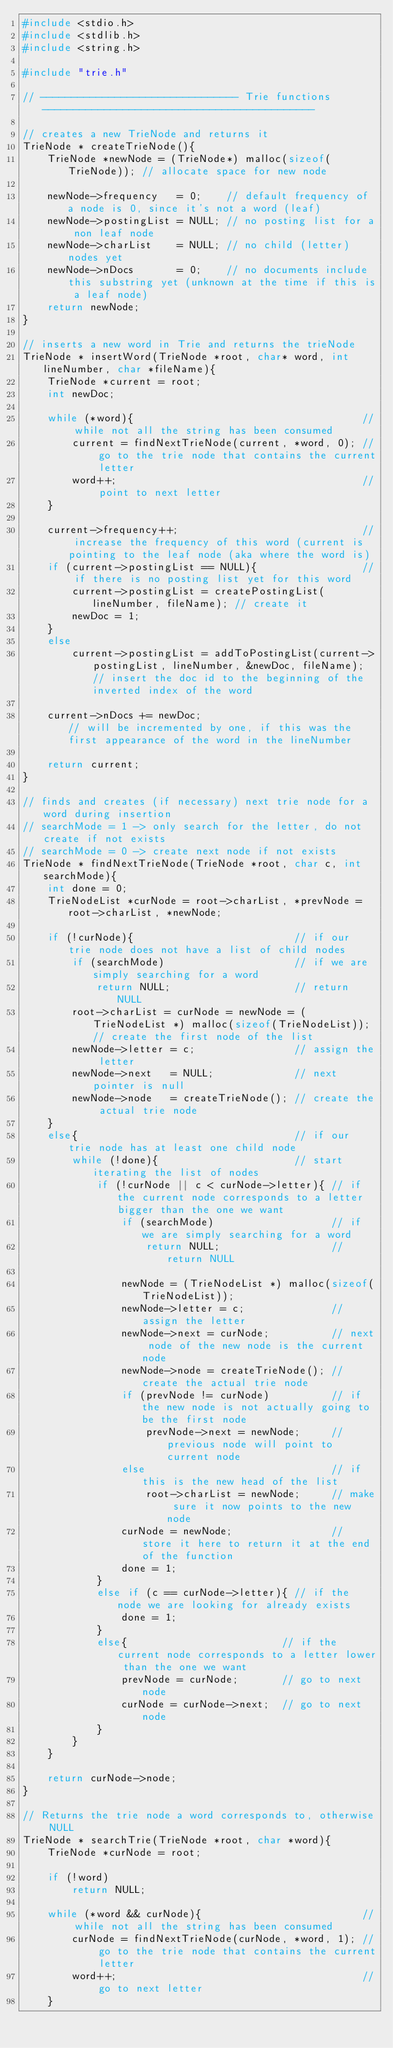<code> <loc_0><loc_0><loc_500><loc_500><_C_>#include <stdio.h>
#include <stdlib.h>
#include <string.h>

#include "trie.h"

// -------------------------------- Trie functions --------------------------------------------

// creates a new TrieNode and returns it
TrieNode * createTrieNode(){
    TrieNode *newNode = (TrieNode*) malloc(sizeof(TrieNode)); // allocate space for new node

    newNode->frequency   = 0;    // default frequency of a node is 0, since it's not a word (leaf)
    newNode->postingList = NULL; // no posting list for a non leaf node
    newNode->charList    = NULL; // no child (letter) nodes yet
    newNode->nDocs       = 0;    // no documents include this substring yet (unknown at the time if this is a leaf node)
    return newNode;
}

// inserts a new word in Trie and returns the trieNode
TrieNode * insertWord(TrieNode *root, char* word, int lineNumber, char *fileName){
    TrieNode *current = root;
    int newDoc;

    while (*word){                                     // while not all the string has been consumed
        current = findNextTrieNode(current, *word, 0); // go to the trie node that contains the current letter
        word++;                                        // point to next letter
    }

    current->frequency++;                              // increase the frequency of this word (current is pointing to the leaf node (aka where the word is)
    if (current->postingList == NULL){                 // if there is no posting list yet for this word
        current->postingList = createPostingList(lineNumber, fileName); // create it
        newDoc = 1;
    }
    else
        current->postingList = addToPostingList(current->postingList, lineNumber, &newDoc, fileName); // insert the doc id to the beginning of the inverted index of the word

    current->nDocs += newDoc;                           // will be incremented by one, if this was the first appearance of the word in the lineNumber

    return current;
}

// finds and creates (if necessary) next trie node for a word during insertion
// searchMode = 1 -> only search for the letter, do not create if not exists
// searchMode = 0 -> create next node if not exists
TrieNode * findNextTrieNode(TrieNode *root, char c, int searchMode){
    int done = 0;
    TrieNodeList *curNode = root->charList, *prevNode = root->charList, *newNode;

    if (!curNode){                          // if our trie node does not have a list of child nodes
        if (searchMode)                     // if we are simply searching for a word
            return NULL;                    // return NULL
        root->charList = curNode = newNode = (TrieNodeList *) malloc(sizeof(TrieNodeList)); // create the first node of the list
        newNode->letter = c;                // assign the letter
        newNode->next   = NULL;             // next pointer is null
        newNode->node   = createTrieNode(); // create the actual trie node
    }
    else{                                   // if our trie node has at least one child node
        while (!done){                      // start iterating the list of nodes
            if (!curNode || c < curNode->letter){ // if the current node corresponds to a letter bigger than the one we want
                if (searchMode)                   // if we are simply searching for a word
                    return NULL;                  // return NULL

                newNode = (TrieNodeList *) malloc(sizeof(TrieNodeList));
                newNode->letter = c;              // assign the letter
                newNode->next = curNode;          // next node of the new node is the current node
                newNode->node = createTrieNode(); // create the actual trie node
                if (prevNode != curNode)          // if the new node is not actually going to be the first node
                    prevNode->next = newNode;     // previous node will point to current node
                else                              // if this is the new head of the list
                    root->charList = newNode;     // make sure it now points to the new node
                curNode = newNode;                // store it here to return it at the end of the function
                done = 1;
            }
            else if (c == curNode->letter){ // if the node we are looking for already exists
                done = 1;
            }
            else{                         // if the current node corresponds to a letter lower than the one we want
                prevNode = curNode;       // go to next node
                curNode = curNode->next;  // go to next node
            }
        }
    }

    return curNode->node;
}

// Returns the trie node a word corresponds to, otherwise NULL
TrieNode * searchTrie(TrieNode *root, char *word){
    TrieNode *curNode = root;

    if (!word)
        return NULL;

    while (*word && curNode){                          // while not all the string has been consumed
        curNode = findNextTrieNode(curNode, *word, 1); // go to the trie node that contains the current letter
        word++;                                        // go to next letter
    }
</code> 